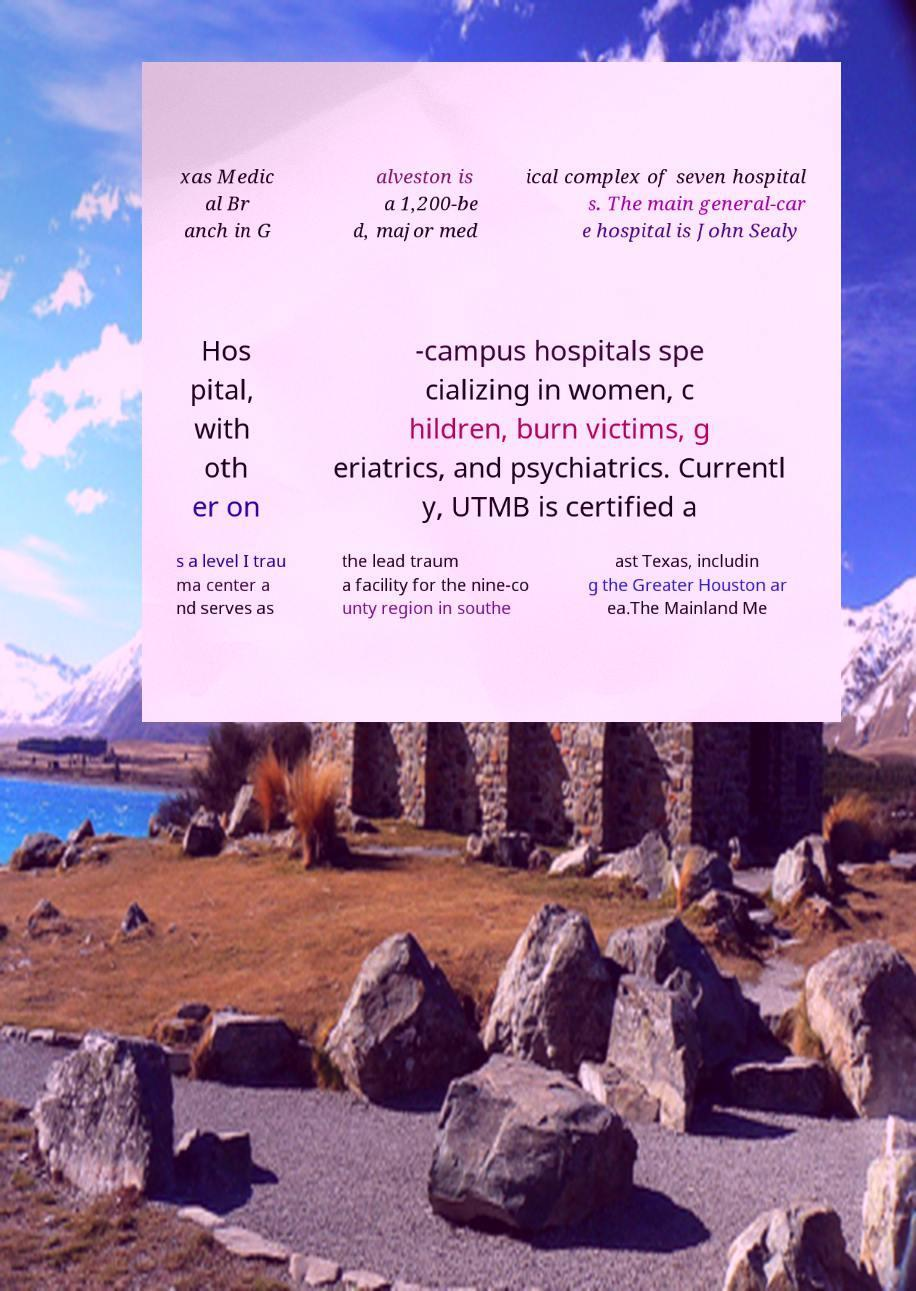Please read and relay the text visible in this image. What does it say? xas Medic al Br anch in G alveston is a 1,200-be d, major med ical complex of seven hospital s. The main general-car e hospital is John Sealy Hos pital, with oth er on -campus hospitals spe cializing in women, c hildren, burn victims, g eriatrics, and psychiatrics. Currentl y, UTMB is certified a s a level I trau ma center a nd serves as the lead traum a facility for the nine-co unty region in southe ast Texas, includin g the Greater Houston ar ea.The Mainland Me 